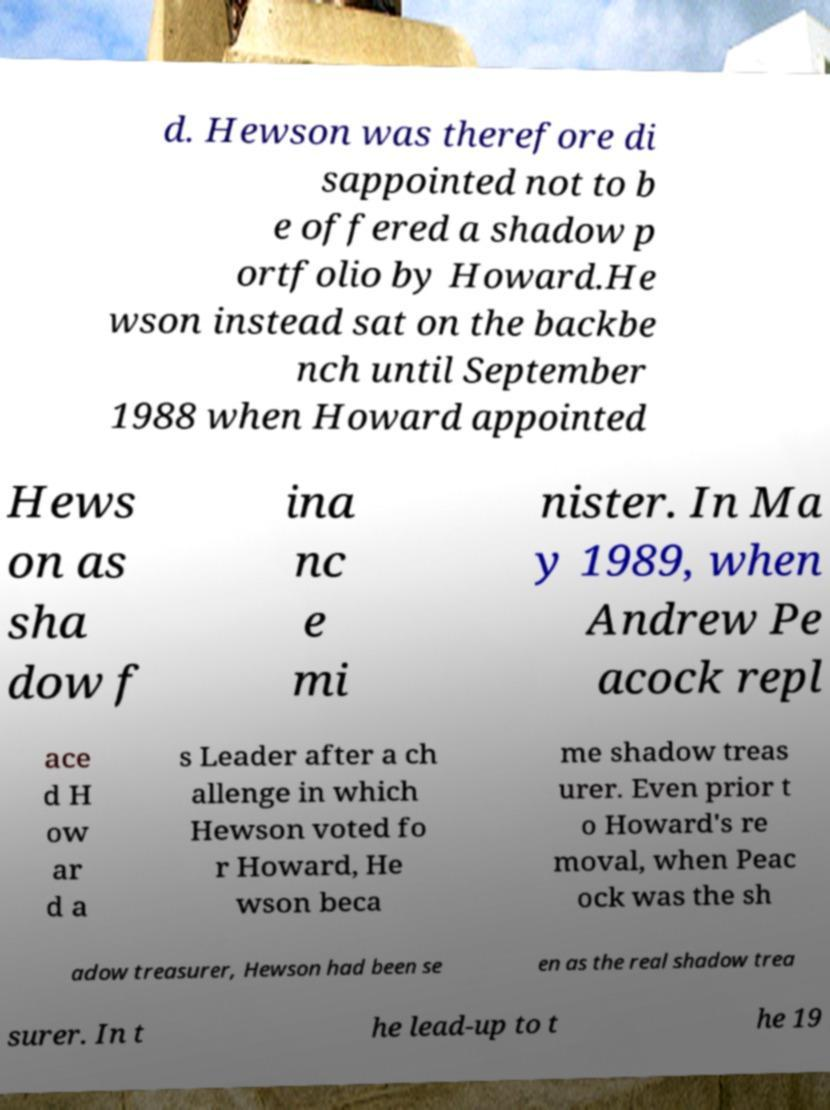Please read and relay the text visible in this image. What does it say? d. Hewson was therefore di sappointed not to b e offered a shadow p ortfolio by Howard.He wson instead sat on the backbe nch until September 1988 when Howard appointed Hews on as sha dow f ina nc e mi nister. In Ma y 1989, when Andrew Pe acock repl ace d H ow ar d a s Leader after a ch allenge in which Hewson voted fo r Howard, He wson beca me shadow treas urer. Even prior t o Howard's re moval, when Peac ock was the sh adow treasurer, Hewson had been se en as the real shadow trea surer. In t he lead-up to t he 19 